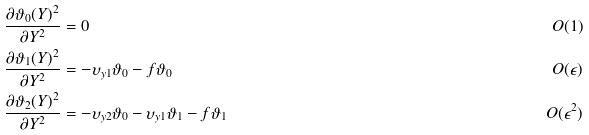Convert formula to latex. <formula><loc_0><loc_0><loc_500><loc_500>\frac { \partial \vartheta _ { 0 } ( Y ) ^ { 2 } } { \partial Y ^ { 2 } } & = 0 & O ( 1 ) \\ \frac { \partial \vartheta _ { 1 } ( Y ) ^ { 2 } } { \partial Y ^ { 2 } } & = - \upsilon _ { y 1 } \vartheta _ { 0 } - f \vartheta _ { 0 } & O ( \epsilon ) \\ \frac { \partial \vartheta _ { 2 } ( Y ) ^ { 2 } } { \partial Y ^ { 2 } } & = - \upsilon _ { y 2 } \vartheta _ { 0 } - \upsilon _ { y 1 } \vartheta _ { 1 } - f \vartheta _ { 1 } & O ( \epsilon ^ { 2 } )</formula> 